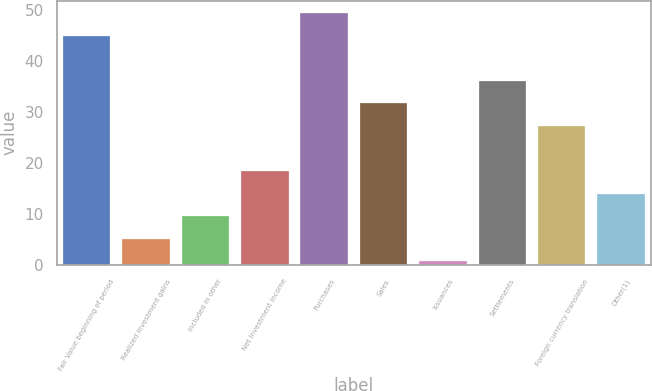Convert chart to OTSL. <chart><loc_0><loc_0><loc_500><loc_500><bar_chart><fcel>Fair Value beginning of period<fcel>Realized investment gains<fcel>Included in other<fcel>Net investment income<fcel>Purchases<fcel>Sales<fcel>Issuances<fcel>Settlements<fcel>Foreign currency translation<fcel>Other(1)<nl><fcel>45.02<fcel>5.15<fcel>9.58<fcel>18.44<fcel>49.45<fcel>31.73<fcel>0.72<fcel>36.16<fcel>27.3<fcel>14.01<nl></chart> 